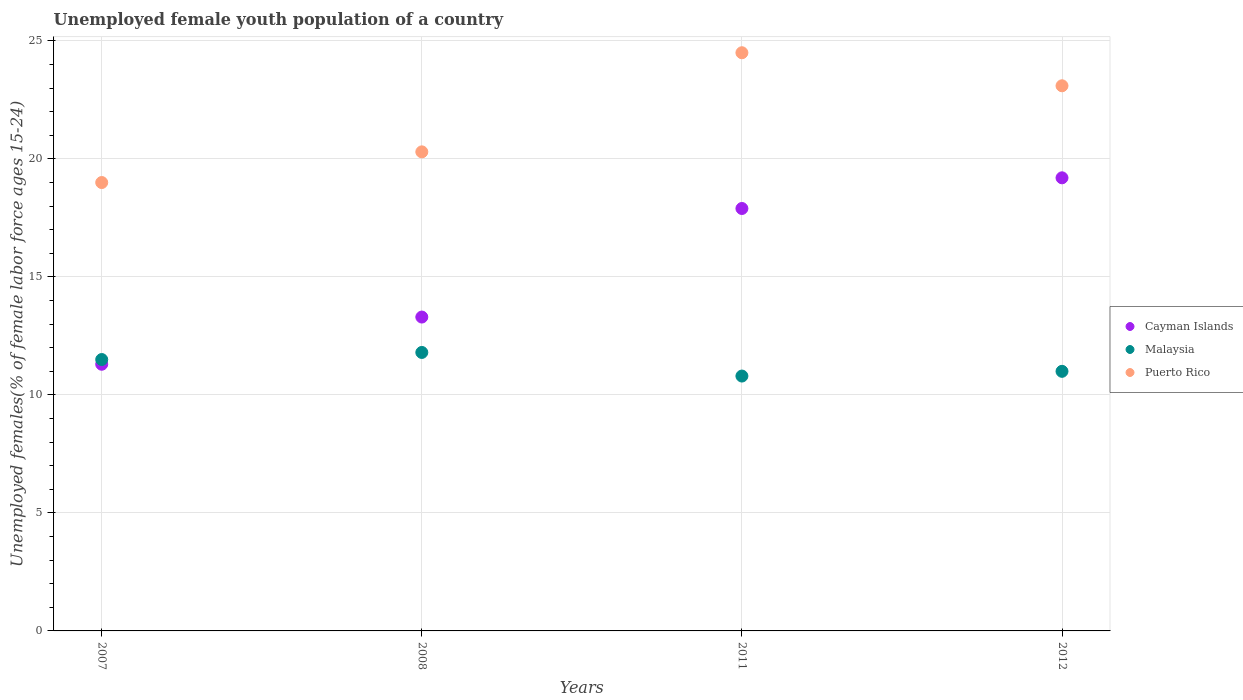Is the number of dotlines equal to the number of legend labels?
Offer a terse response. Yes. What is the percentage of unemployed female youth population in Malaysia in 2011?
Provide a short and direct response. 10.8. Across all years, what is the minimum percentage of unemployed female youth population in Malaysia?
Offer a very short reply. 10.8. In which year was the percentage of unemployed female youth population in Puerto Rico minimum?
Keep it short and to the point. 2007. What is the total percentage of unemployed female youth population in Cayman Islands in the graph?
Ensure brevity in your answer.  61.7. What is the difference between the percentage of unemployed female youth population in Malaysia in 2007 and that in 2011?
Your answer should be very brief. 0.7. What is the difference between the percentage of unemployed female youth population in Malaysia in 2011 and the percentage of unemployed female youth population in Puerto Rico in 2007?
Make the answer very short. -8.2. What is the average percentage of unemployed female youth population in Malaysia per year?
Give a very brief answer. 11.28. In the year 2012, what is the difference between the percentage of unemployed female youth population in Cayman Islands and percentage of unemployed female youth population in Malaysia?
Your answer should be very brief. 8.2. What is the ratio of the percentage of unemployed female youth population in Puerto Rico in 2011 to that in 2012?
Offer a terse response. 1.06. What is the difference between the highest and the second highest percentage of unemployed female youth population in Malaysia?
Make the answer very short. 0.3. Is the sum of the percentage of unemployed female youth population in Cayman Islands in 2007 and 2011 greater than the maximum percentage of unemployed female youth population in Malaysia across all years?
Offer a very short reply. Yes. Does the percentage of unemployed female youth population in Cayman Islands monotonically increase over the years?
Give a very brief answer. Yes. Is the percentage of unemployed female youth population in Cayman Islands strictly greater than the percentage of unemployed female youth population in Malaysia over the years?
Ensure brevity in your answer.  No. How many dotlines are there?
Your response must be concise. 3. Are the values on the major ticks of Y-axis written in scientific E-notation?
Offer a very short reply. No. How many legend labels are there?
Keep it short and to the point. 3. What is the title of the graph?
Keep it short and to the point. Unemployed female youth population of a country. What is the label or title of the Y-axis?
Your answer should be compact. Unemployed females(% of female labor force ages 15-24). What is the Unemployed females(% of female labor force ages 15-24) of Cayman Islands in 2007?
Provide a succinct answer. 11.3. What is the Unemployed females(% of female labor force ages 15-24) of Malaysia in 2007?
Keep it short and to the point. 11.5. What is the Unemployed females(% of female labor force ages 15-24) of Puerto Rico in 2007?
Keep it short and to the point. 19. What is the Unemployed females(% of female labor force ages 15-24) of Cayman Islands in 2008?
Ensure brevity in your answer.  13.3. What is the Unemployed females(% of female labor force ages 15-24) in Malaysia in 2008?
Your response must be concise. 11.8. What is the Unemployed females(% of female labor force ages 15-24) of Puerto Rico in 2008?
Ensure brevity in your answer.  20.3. What is the Unemployed females(% of female labor force ages 15-24) in Cayman Islands in 2011?
Keep it short and to the point. 17.9. What is the Unemployed females(% of female labor force ages 15-24) in Malaysia in 2011?
Your response must be concise. 10.8. What is the Unemployed females(% of female labor force ages 15-24) in Cayman Islands in 2012?
Offer a very short reply. 19.2. What is the Unemployed females(% of female labor force ages 15-24) in Puerto Rico in 2012?
Your answer should be very brief. 23.1. Across all years, what is the maximum Unemployed females(% of female labor force ages 15-24) of Cayman Islands?
Make the answer very short. 19.2. Across all years, what is the maximum Unemployed females(% of female labor force ages 15-24) in Malaysia?
Ensure brevity in your answer.  11.8. Across all years, what is the minimum Unemployed females(% of female labor force ages 15-24) of Cayman Islands?
Your answer should be compact. 11.3. Across all years, what is the minimum Unemployed females(% of female labor force ages 15-24) of Malaysia?
Provide a short and direct response. 10.8. What is the total Unemployed females(% of female labor force ages 15-24) of Cayman Islands in the graph?
Your answer should be very brief. 61.7. What is the total Unemployed females(% of female labor force ages 15-24) of Malaysia in the graph?
Your answer should be compact. 45.1. What is the total Unemployed females(% of female labor force ages 15-24) in Puerto Rico in the graph?
Ensure brevity in your answer.  86.9. What is the difference between the Unemployed females(% of female labor force ages 15-24) in Malaysia in 2007 and that in 2008?
Your answer should be compact. -0.3. What is the difference between the Unemployed females(% of female labor force ages 15-24) of Malaysia in 2007 and that in 2011?
Offer a terse response. 0.7. What is the difference between the Unemployed females(% of female labor force ages 15-24) in Cayman Islands in 2007 and that in 2012?
Give a very brief answer. -7.9. What is the difference between the Unemployed females(% of female labor force ages 15-24) in Malaysia in 2007 and that in 2012?
Make the answer very short. 0.5. What is the difference between the Unemployed females(% of female labor force ages 15-24) of Puerto Rico in 2007 and that in 2012?
Your response must be concise. -4.1. What is the difference between the Unemployed females(% of female labor force ages 15-24) in Cayman Islands in 2008 and that in 2011?
Your response must be concise. -4.6. What is the difference between the Unemployed females(% of female labor force ages 15-24) of Malaysia in 2008 and that in 2012?
Offer a very short reply. 0.8. What is the difference between the Unemployed females(% of female labor force ages 15-24) of Puerto Rico in 2008 and that in 2012?
Keep it short and to the point. -2.8. What is the difference between the Unemployed females(% of female labor force ages 15-24) in Puerto Rico in 2011 and that in 2012?
Your response must be concise. 1.4. What is the difference between the Unemployed females(% of female labor force ages 15-24) of Cayman Islands in 2007 and the Unemployed females(% of female labor force ages 15-24) of Puerto Rico in 2008?
Offer a terse response. -9. What is the difference between the Unemployed females(% of female labor force ages 15-24) in Cayman Islands in 2007 and the Unemployed females(% of female labor force ages 15-24) in Puerto Rico in 2011?
Provide a succinct answer. -13.2. What is the difference between the Unemployed females(% of female labor force ages 15-24) in Cayman Islands in 2007 and the Unemployed females(% of female labor force ages 15-24) in Malaysia in 2012?
Offer a very short reply. 0.3. What is the difference between the Unemployed females(% of female labor force ages 15-24) in Cayman Islands in 2007 and the Unemployed females(% of female labor force ages 15-24) in Puerto Rico in 2012?
Your response must be concise. -11.8. What is the difference between the Unemployed females(% of female labor force ages 15-24) of Cayman Islands in 2008 and the Unemployed females(% of female labor force ages 15-24) of Puerto Rico in 2011?
Give a very brief answer. -11.2. What is the difference between the Unemployed females(% of female labor force ages 15-24) in Malaysia in 2008 and the Unemployed females(% of female labor force ages 15-24) in Puerto Rico in 2011?
Your answer should be compact. -12.7. What is the difference between the Unemployed females(% of female labor force ages 15-24) of Malaysia in 2008 and the Unemployed females(% of female labor force ages 15-24) of Puerto Rico in 2012?
Offer a terse response. -11.3. What is the difference between the Unemployed females(% of female labor force ages 15-24) of Cayman Islands in 2011 and the Unemployed females(% of female labor force ages 15-24) of Malaysia in 2012?
Give a very brief answer. 6.9. What is the difference between the Unemployed females(% of female labor force ages 15-24) in Malaysia in 2011 and the Unemployed females(% of female labor force ages 15-24) in Puerto Rico in 2012?
Keep it short and to the point. -12.3. What is the average Unemployed females(% of female labor force ages 15-24) of Cayman Islands per year?
Provide a short and direct response. 15.43. What is the average Unemployed females(% of female labor force ages 15-24) in Malaysia per year?
Your answer should be compact. 11.28. What is the average Unemployed females(% of female labor force ages 15-24) of Puerto Rico per year?
Ensure brevity in your answer.  21.73. In the year 2007, what is the difference between the Unemployed females(% of female labor force ages 15-24) of Cayman Islands and Unemployed females(% of female labor force ages 15-24) of Malaysia?
Provide a succinct answer. -0.2. In the year 2008, what is the difference between the Unemployed females(% of female labor force ages 15-24) in Cayman Islands and Unemployed females(% of female labor force ages 15-24) in Puerto Rico?
Offer a terse response. -7. In the year 2008, what is the difference between the Unemployed females(% of female labor force ages 15-24) in Malaysia and Unemployed females(% of female labor force ages 15-24) in Puerto Rico?
Offer a very short reply. -8.5. In the year 2011, what is the difference between the Unemployed females(% of female labor force ages 15-24) of Cayman Islands and Unemployed females(% of female labor force ages 15-24) of Malaysia?
Provide a short and direct response. 7.1. In the year 2011, what is the difference between the Unemployed females(% of female labor force ages 15-24) of Cayman Islands and Unemployed females(% of female labor force ages 15-24) of Puerto Rico?
Provide a succinct answer. -6.6. In the year 2011, what is the difference between the Unemployed females(% of female labor force ages 15-24) of Malaysia and Unemployed females(% of female labor force ages 15-24) of Puerto Rico?
Your answer should be compact. -13.7. In the year 2012, what is the difference between the Unemployed females(% of female labor force ages 15-24) of Cayman Islands and Unemployed females(% of female labor force ages 15-24) of Malaysia?
Keep it short and to the point. 8.2. In the year 2012, what is the difference between the Unemployed females(% of female labor force ages 15-24) of Malaysia and Unemployed females(% of female labor force ages 15-24) of Puerto Rico?
Make the answer very short. -12.1. What is the ratio of the Unemployed females(% of female labor force ages 15-24) of Cayman Islands in 2007 to that in 2008?
Provide a short and direct response. 0.85. What is the ratio of the Unemployed females(% of female labor force ages 15-24) in Malaysia in 2007 to that in 2008?
Your answer should be very brief. 0.97. What is the ratio of the Unemployed females(% of female labor force ages 15-24) in Puerto Rico in 2007 to that in 2008?
Keep it short and to the point. 0.94. What is the ratio of the Unemployed females(% of female labor force ages 15-24) in Cayman Islands in 2007 to that in 2011?
Your answer should be compact. 0.63. What is the ratio of the Unemployed females(% of female labor force ages 15-24) in Malaysia in 2007 to that in 2011?
Your answer should be compact. 1.06. What is the ratio of the Unemployed females(% of female labor force ages 15-24) in Puerto Rico in 2007 to that in 2011?
Offer a terse response. 0.78. What is the ratio of the Unemployed females(% of female labor force ages 15-24) in Cayman Islands in 2007 to that in 2012?
Your response must be concise. 0.59. What is the ratio of the Unemployed females(% of female labor force ages 15-24) of Malaysia in 2007 to that in 2012?
Provide a short and direct response. 1.05. What is the ratio of the Unemployed females(% of female labor force ages 15-24) of Puerto Rico in 2007 to that in 2012?
Give a very brief answer. 0.82. What is the ratio of the Unemployed females(% of female labor force ages 15-24) in Cayman Islands in 2008 to that in 2011?
Make the answer very short. 0.74. What is the ratio of the Unemployed females(% of female labor force ages 15-24) of Malaysia in 2008 to that in 2011?
Your answer should be very brief. 1.09. What is the ratio of the Unemployed females(% of female labor force ages 15-24) in Puerto Rico in 2008 to that in 2011?
Offer a terse response. 0.83. What is the ratio of the Unemployed females(% of female labor force ages 15-24) in Cayman Islands in 2008 to that in 2012?
Keep it short and to the point. 0.69. What is the ratio of the Unemployed females(% of female labor force ages 15-24) of Malaysia in 2008 to that in 2012?
Offer a terse response. 1.07. What is the ratio of the Unemployed females(% of female labor force ages 15-24) of Puerto Rico in 2008 to that in 2012?
Your response must be concise. 0.88. What is the ratio of the Unemployed females(% of female labor force ages 15-24) of Cayman Islands in 2011 to that in 2012?
Keep it short and to the point. 0.93. What is the ratio of the Unemployed females(% of female labor force ages 15-24) in Malaysia in 2011 to that in 2012?
Ensure brevity in your answer.  0.98. What is the ratio of the Unemployed females(% of female labor force ages 15-24) of Puerto Rico in 2011 to that in 2012?
Your answer should be very brief. 1.06. What is the difference between the highest and the second highest Unemployed females(% of female labor force ages 15-24) of Cayman Islands?
Provide a succinct answer. 1.3. What is the difference between the highest and the second highest Unemployed females(% of female labor force ages 15-24) in Puerto Rico?
Your answer should be compact. 1.4. What is the difference between the highest and the lowest Unemployed females(% of female labor force ages 15-24) in Cayman Islands?
Offer a terse response. 7.9. What is the difference between the highest and the lowest Unemployed females(% of female labor force ages 15-24) in Malaysia?
Your response must be concise. 1. What is the difference between the highest and the lowest Unemployed females(% of female labor force ages 15-24) of Puerto Rico?
Provide a short and direct response. 5.5. 